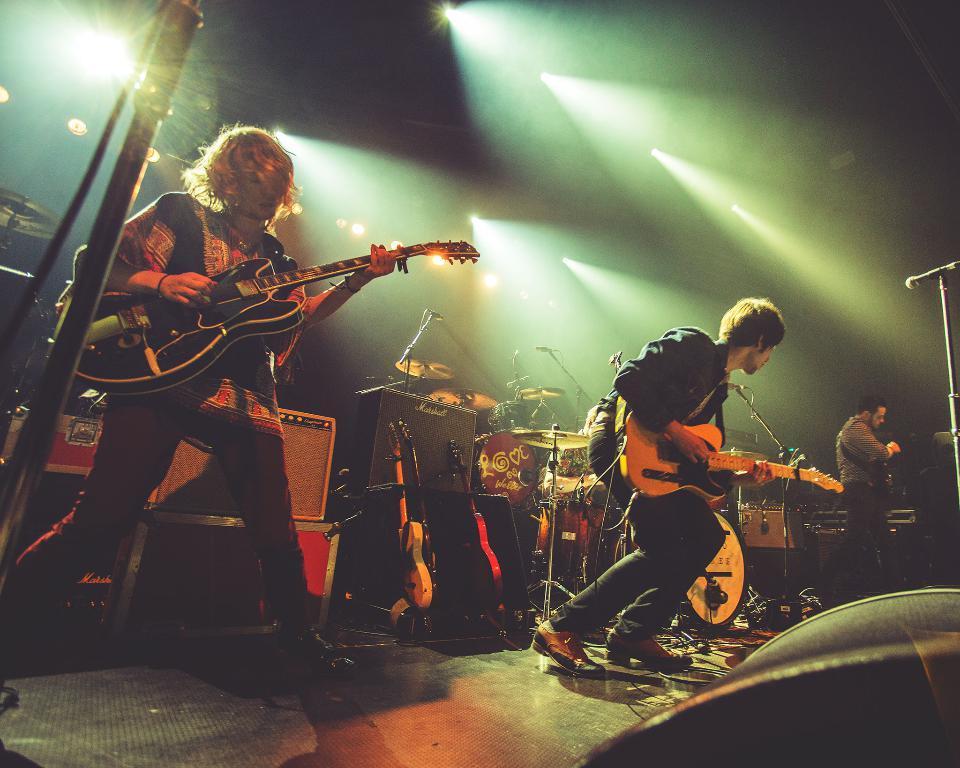How would you summarize this image in a sentence or two? In this image I can see the stage, few persons standing on the stage holding musical instruments, few microphones and behind them I can see few musical instruments and few boxes. I can see few lights and the dark background. 